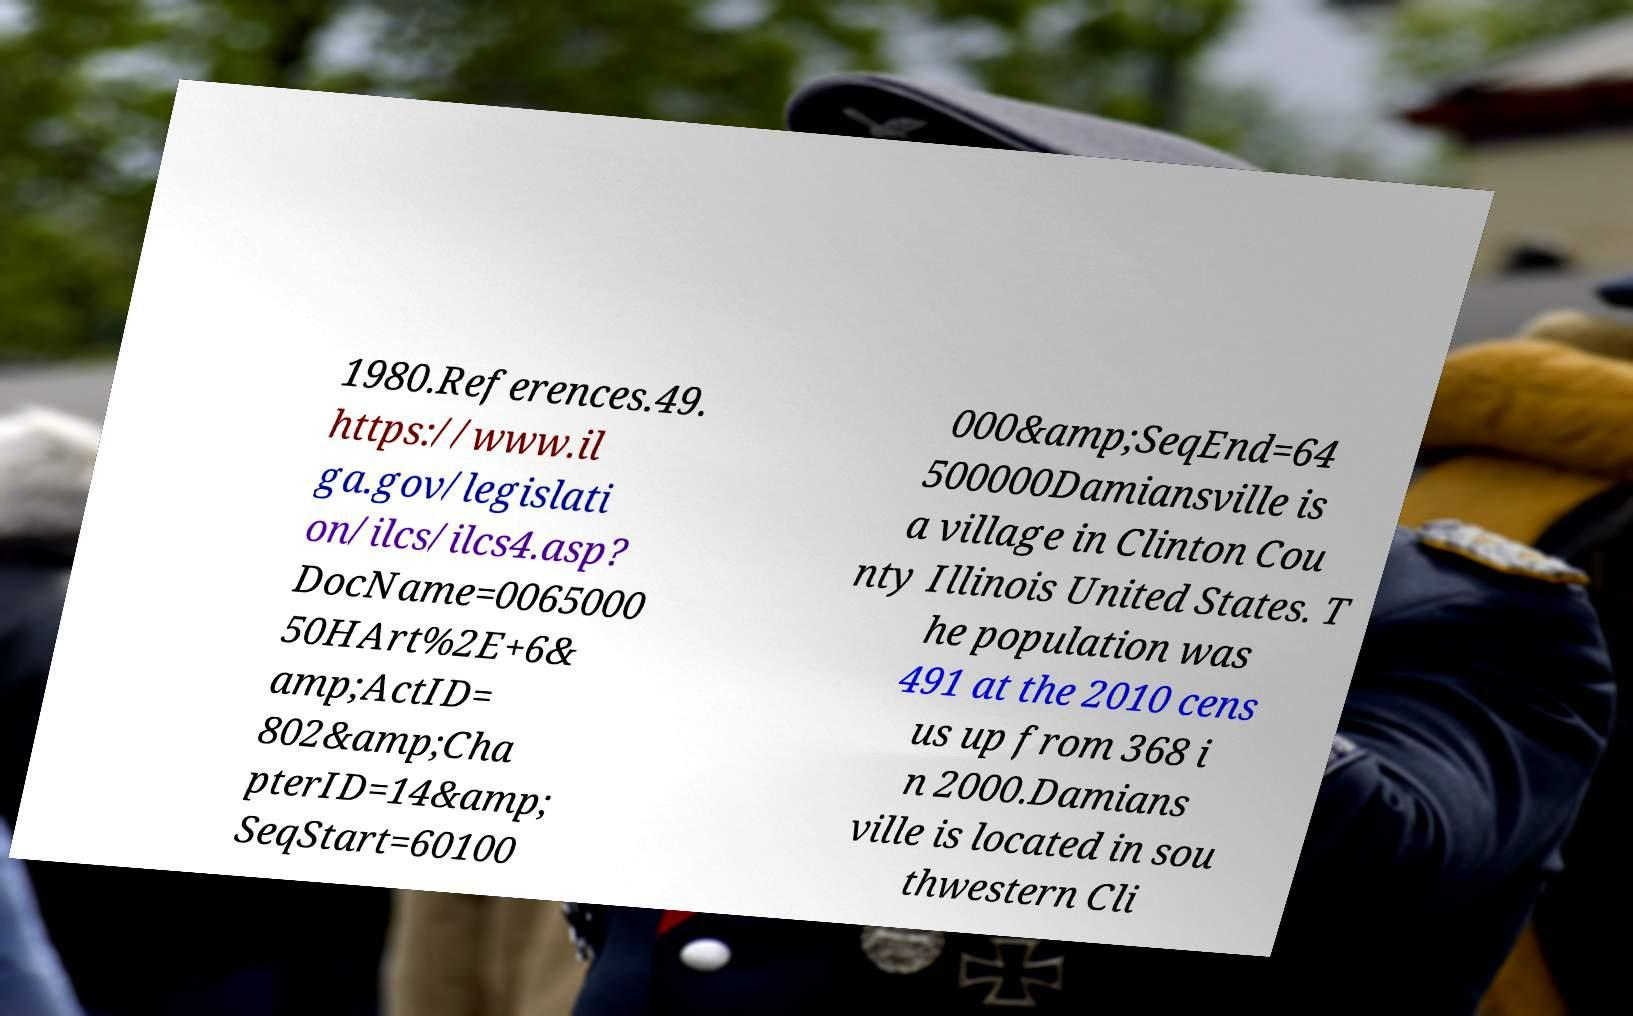For documentation purposes, I need the text within this image transcribed. Could you provide that? 1980.References.49. https://www.il ga.gov/legislati on/ilcs/ilcs4.asp? DocName=0065000 50HArt%2E+6& amp;ActID= 802&amp;Cha pterID=14&amp; SeqStart=60100 000&amp;SeqEnd=64 500000Damiansville is a village in Clinton Cou nty Illinois United States. T he population was 491 at the 2010 cens us up from 368 i n 2000.Damians ville is located in sou thwestern Cli 